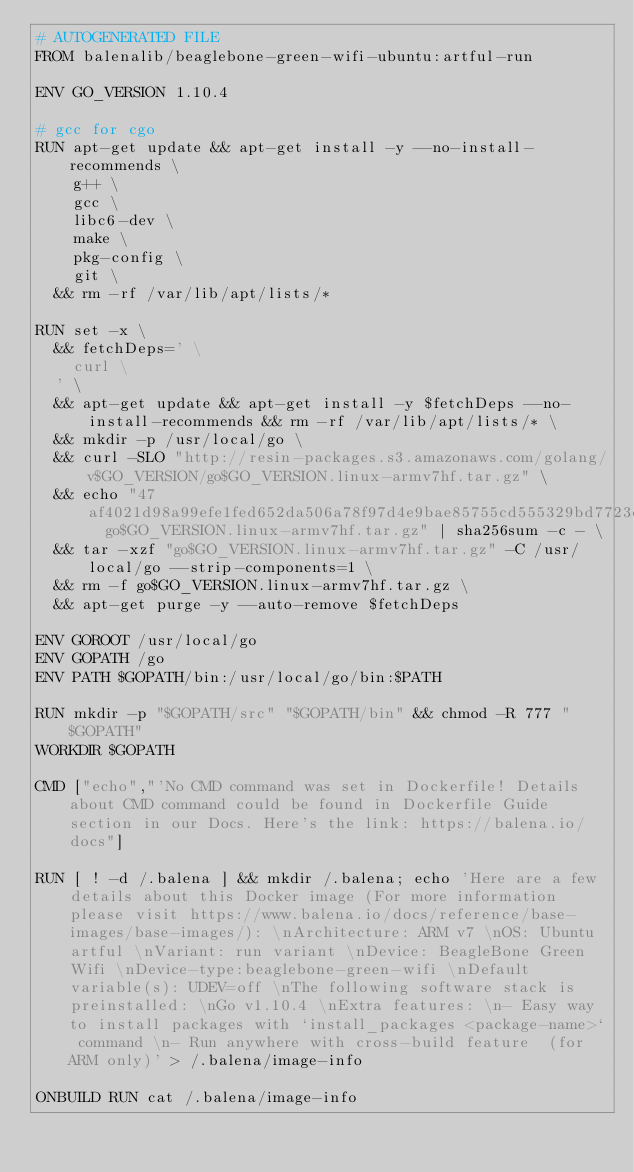Convert code to text. <code><loc_0><loc_0><loc_500><loc_500><_Dockerfile_># AUTOGENERATED FILE
FROM balenalib/beaglebone-green-wifi-ubuntu:artful-run

ENV GO_VERSION 1.10.4

# gcc for cgo
RUN apt-get update && apt-get install -y --no-install-recommends \
		g++ \
		gcc \
		libc6-dev \
		make \
		pkg-config \
		git \
	&& rm -rf /var/lib/apt/lists/*

RUN set -x \
	&& fetchDeps=' \
		curl \
	' \
	&& apt-get update && apt-get install -y $fetchDeps --no-install-recommends && rm -rf /var/lib/apt/lists/* \
	&& mkdir -p /usr/local/go \
	&& curl -SLO "http://resin-packages.s3.amazonaws.com/golang/v$GO_VERSION/go$GO_VERSION.linux-armv7hf.tar.gz" \
	&& echo "47af4021d98a99efe1fed652da506a78f97d4e9bae85755cd555329bd7723cc3  go$GO_VERSION.linux-armv7hf.tar.gz" | sha256sum -c - \
	&& tar -xzf "go$GO_VERSION.linux-armv7hf.tar.gz" -C /usr/local/go --strip-components=1 \
	&& rm -f go$GO_VERSION.linux-armv7hf.tar.gz \
	&& apt-get purge -y --auto-remove $fetchDeps

ENV GOROOT /usr/local/go
ENV GOPATH /go
ENV PATH $GOPATH/bin:/usr/local/go/bin:$PATH

RUN mkdir -p "$GOPATH/src" "$GOPATH/bin" && chmod -R 777 "$GOPATH"
WORKDIR $GOPATH

CMD ["echo","'No CMD command was set in Dockerfile! Details about CMD command could be found in Dockerfile Guide section in our Docs. Here's the link: https://balena.io/docs"]

RUN [ ! -d /.balena ] && mkdir /.balena; echo 'Here are a few details about this Docker image (For more information please visit https://www.balena.io/docs/reference/base-images/base-images/): \nArchitecture: ARM v7 \nOS: Ubuntu artful \nVariant: run variant \nDevice: BeagleBone Green Wifi \nDevice-type:beaglebone-green-wifi \nDefault variable(s): UDEV=off \nThe following software stack is preinstalled: \nGo v1.10.4 \nExtra features: \n- Easy way to install packages with `install_packages <package-name>` command \n- Run anywhere with cross-build feature  (for ARM only)' > /.balena/image-info

ONBUILD RUN cat /.balena/image-info</code> 